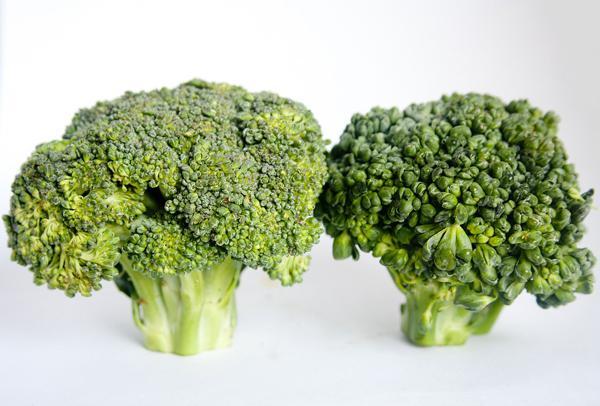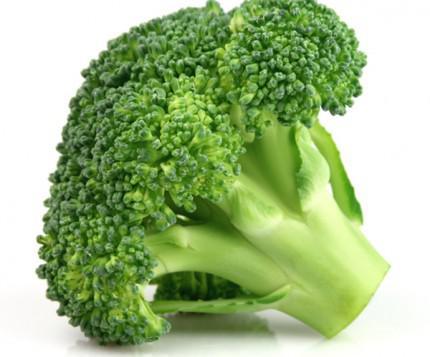The first image is the image on the left, the second image is the image on the right. For the images displayed, is the sentence "Images show a total of five broccoli florets arranged horizontally." factually correct? Answer yes or no. No. 